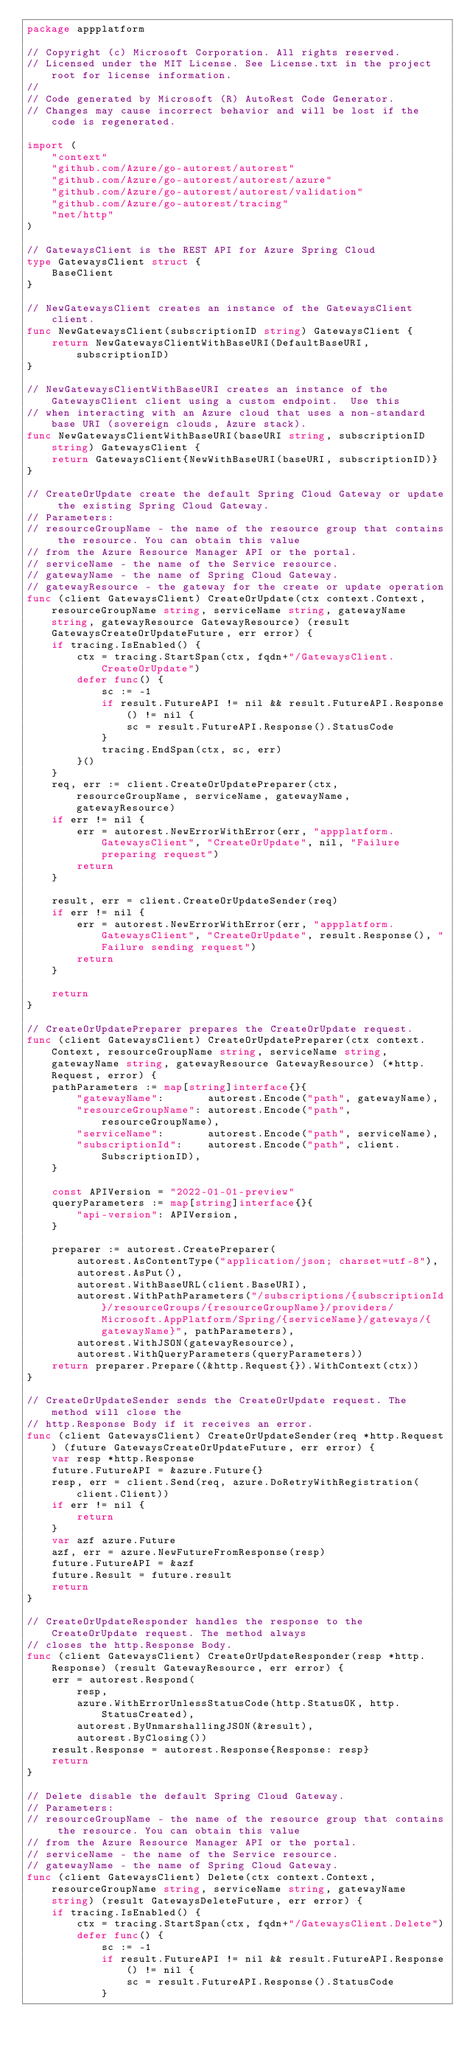Convert code to text. <code><loc_0><loc_0><loc_500><loc_500><_Go_>package appplatform

// Copyright (c) Microsoft Corporation. All rights reserved.
// Licensed under the MIT License. See License.txt in the project root for license information.
//
// Code generated by Microsoft (R) AutoRest Code Generator.
// Changes may cause incorrect behavior and will be lost if the code is regenerated.

import (
	"context"
	"github.com/Azure/go-autorest/autorest"
	"github.com/Azure/go-autorest/autorest/azure"
	"github.com/Azure/go-autorest/autorest/validation"
	"github.com/Azure/go-autorest/tracing"
	"net/http"
)

// GatewaysClient is the REST API for Azure Spring Cloud
type GatewaysClient struct {
	BaseClient
}

// NewGatewaysClient creates an instance of the GatewaysClient client.
func NewGatewaysClient(subscriptionID string) GatewaysClient {
	return NewGatewaysClientWithBaseURI(DefaultBaseURI, subscriptionID)
}

// NewGatewaysClientWithBaseURI creates an instance of the GatewaysClient client using a custom endpoint.  Use this
// when interacting with an Azure cloud that uses a non-standard base URI (sovereign clouds, Azure stack).
func NewGatewaysClientWithBaseURI(baseURI string, subscriptionID string) GatewaysClient {
	return GatewaysClient{NewWithBaseURI(baseURI, subscriptionID)}
}

// CreateOrUpdate create the default Spring Cloud Gateway or update the existing Spring Cloud Gateway.
// Parameters:
// resourceGroupName - the name of the resource group that contains the resource. You can obtain this value
// from the Azure Resource Manager API or the portal.
// serviceName - the name of the Service resource.
// gatewayName - the name of Spring Cloud Gateway.
// gatewayResource - the gateway for the create or update operation
func (client GatewaysClient) CreateOrUpdate(ctx context.Context, resourceGroupName string, serviceName string, gatewayName string, gatewayResource GatewayResource) (result GatewaysCreateOrUpdateFuture, err error) {
	if tracing.IsEnabled() {
		ctx = tracing.StartSpan(ctx, fqdn+"/GatewaysClient.CreateOrUpdate")
		defer func() {
			sc := -1
			if result.FutureAPI != nil && result.FutureAPI.Response() != nil {
				sc = result.FutureAPI.Response().StatusCode
			}
			tracing.EndSpan(ctx, sc, err)
		}()
	}
	req, err := client.CreateOrUpdatePreparer(ctx, resourceGroupName, serviceName, gatewayName, gatewayResource)
	if err != nil {
		err = autorest.NewErrorWithError(err, "appplatform.GatewaysClient", "CreateOrUpdate", nil, "Failure preparing request")
		return
	}

	result, err = client.CreateOrUpdateSender(req)
	if err != nil {
		err = autorest.NewErrorWithError(err, "appplatform.GatewaysClient", "CreateOrUpdate", result.Response(), "Failure sending request")
		return
	}

	return
}

// CreateOrUpdatePreparer prepares the CreateOrUpdate request.
func (client GatewaysClient) CreateOrUpdatePreparer(ctx context.Context, resourceGroupName string, serviceName string, gatewayName string, gatewayResource GatewayResource) (*http.Request, error) {
	pathParameters := map[string]interface{}{
		"gatewayName":       autorest.Encode("path", gatewayName),
		"resourceGroupName": autorest.Encode("path", resourceGroupName),
		"serviceName":       autorest.Encode("path", serviceName),
		"subscriptionId":    autorest.Encode("path", client.SubscriptionID),
	}

	const APIVersion = "2022-01-01-preview"
	queryParameters := map[string]interface{}{
		"api-version": APIVersion,
	}

	preparer := autorest.CreatePreparer(
		autorest.AsContentType("application/json; charset=utf-8"),
		autorest.AsPut(),
		autorest.WithBaseURL(client.BaseURI),
		autorest.WithPathParameters("/subscriptions/{subscriptionId}/resourceGroups/{resourceGroupName}/providers/Microsoft.AppPlatform/Spring/{serviceName}/gateways/{gatewayName}", pathParameters),
		autorest.WithJSON(gatewayResource),
		autorest.WithQueryParameters(queryParameters))
	return preparer.Prepare((&http.Request{}).WithContext(ctx))
}

// CreateOrUpdateSender sends the CreateOrUpdate request. The method will close the
// http.Response Body if it receives an error.
func (client GatewaysClient) CreateOrUpdateSender(req *http.Request) (future GatewaysCreateOrUpdateFuture, err error) {
	var resp *http.Response
	future.FutureAPI = &azure.Future{}
	resp, err = client.Send(req, azure.DoRetryWithRegistration(client.Client))
	if err != nil {
		return
	}
	var azf azure.Future
	azf, err = azure.NewFutureFromResponse(resp)
	future.FutureAPI = &azf
	future.Result = future.result
	return
}

// CreateOrUpdateResponder handles the response to the CreateOrUpdate request. The method always
// closes the http.Response Body.
func (client GatewaysClient) CreateOrUpdateResponder(resp *http.Response) (result GatewayResource, err error) {
	err = autorest.Respond(
		resp,
		azure.WithErrorUnlessStatusCode(http.StatusOK, http.StatusCreated),
		autorest.ByUnmarshallingJSON(&result),
		autorest.ByClosing())
	result.Response = autorest.Response{Response: resp}
	return
}

// Delete disable the default Spring Cloud Gateway.
// Parameters:
// resourceGroupName - the name of the resource group that contains the resource. You can obtain this value
// from the Azure Resource Manager API or the portal.
// serviceName - the name of the Service resource.
// gatewayName - the name of Spring Cloud Gateway.
func (client GatewaysClient) Delete(ctx context.Context, resourceGroupName string, serviceName string, gatewayName string) (result GatewaysDeleteFuture, err error) {
	if tracing.IsEnabled() {
		ctx = tracing.StartSpan(ctx, fqdn+"/GatewaysClient.Delete")
		defer func() {
			sc := -1
			if result.FutureAPI != nil && result.FutureAPI.Response() != nil {
				sc = result.FutureAPI.Response().StatusCode
			}</code> 